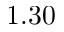<formula> <loc_0><loc_0><loc_500><loc_500>1 . 3 0</formula> 